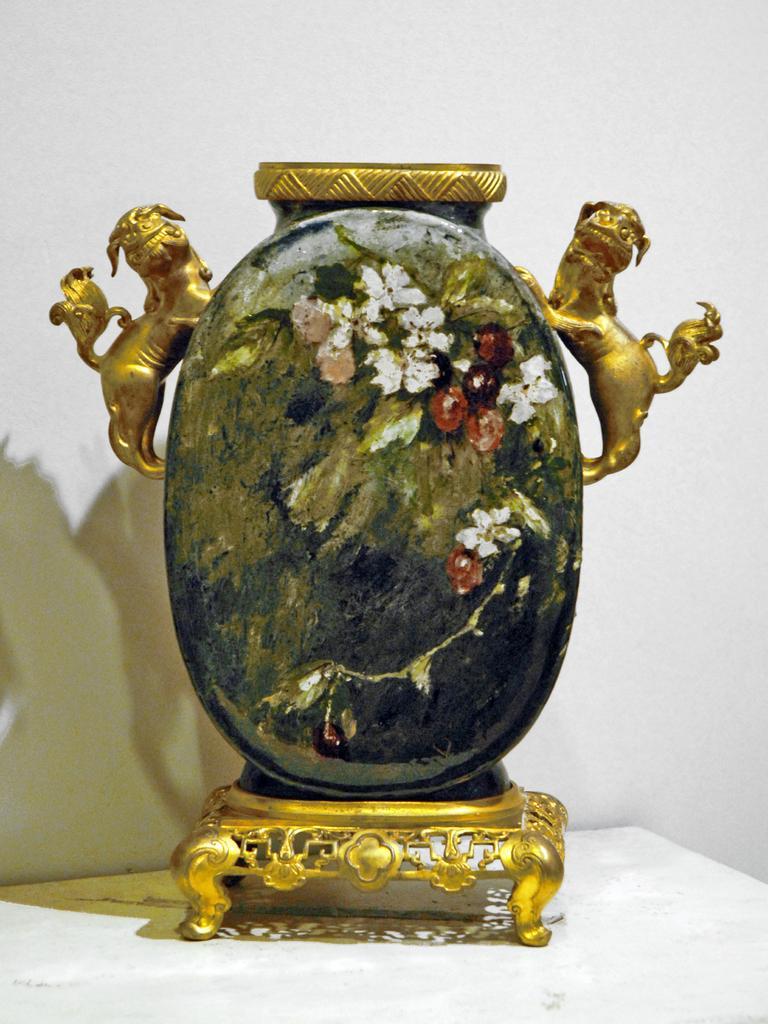How would you summarize this image in a sentence or two? In this image in the center there is some object, and there are two statues of an animals. At the bottom looks like a table and is a white background. 